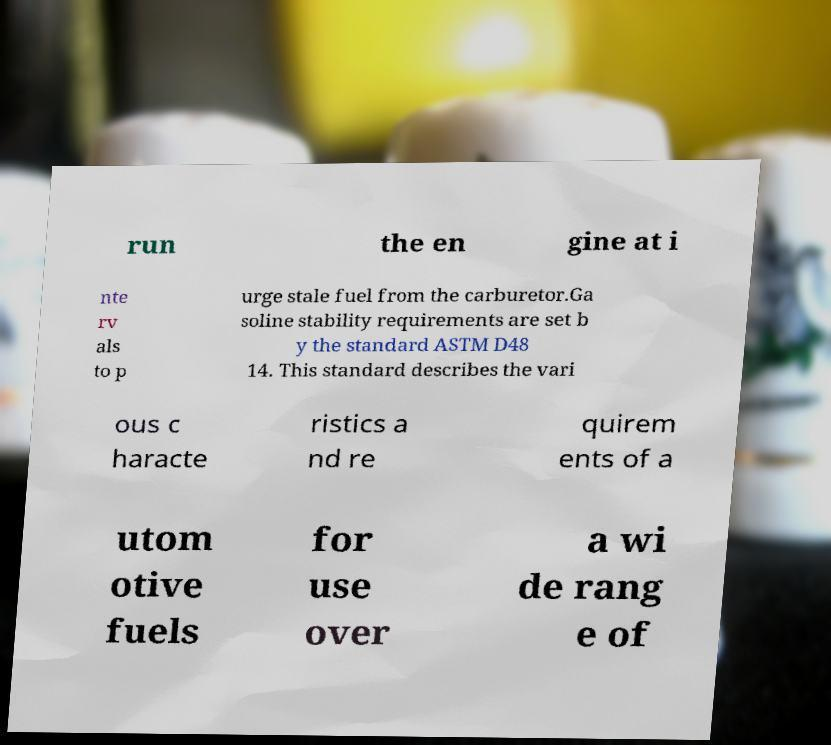What messages or text are displayed in this image? I need them in a readable, typed format. run the en gine at i nte rv als to p urge stale fuel from the carburetor.Ga soline stability requirements are set b y the standard ASTM D48 14. This standard describes the vari ous c haracte ristics a nd re quirem ents of a utom otive fuels for use over a wi de rang e of 